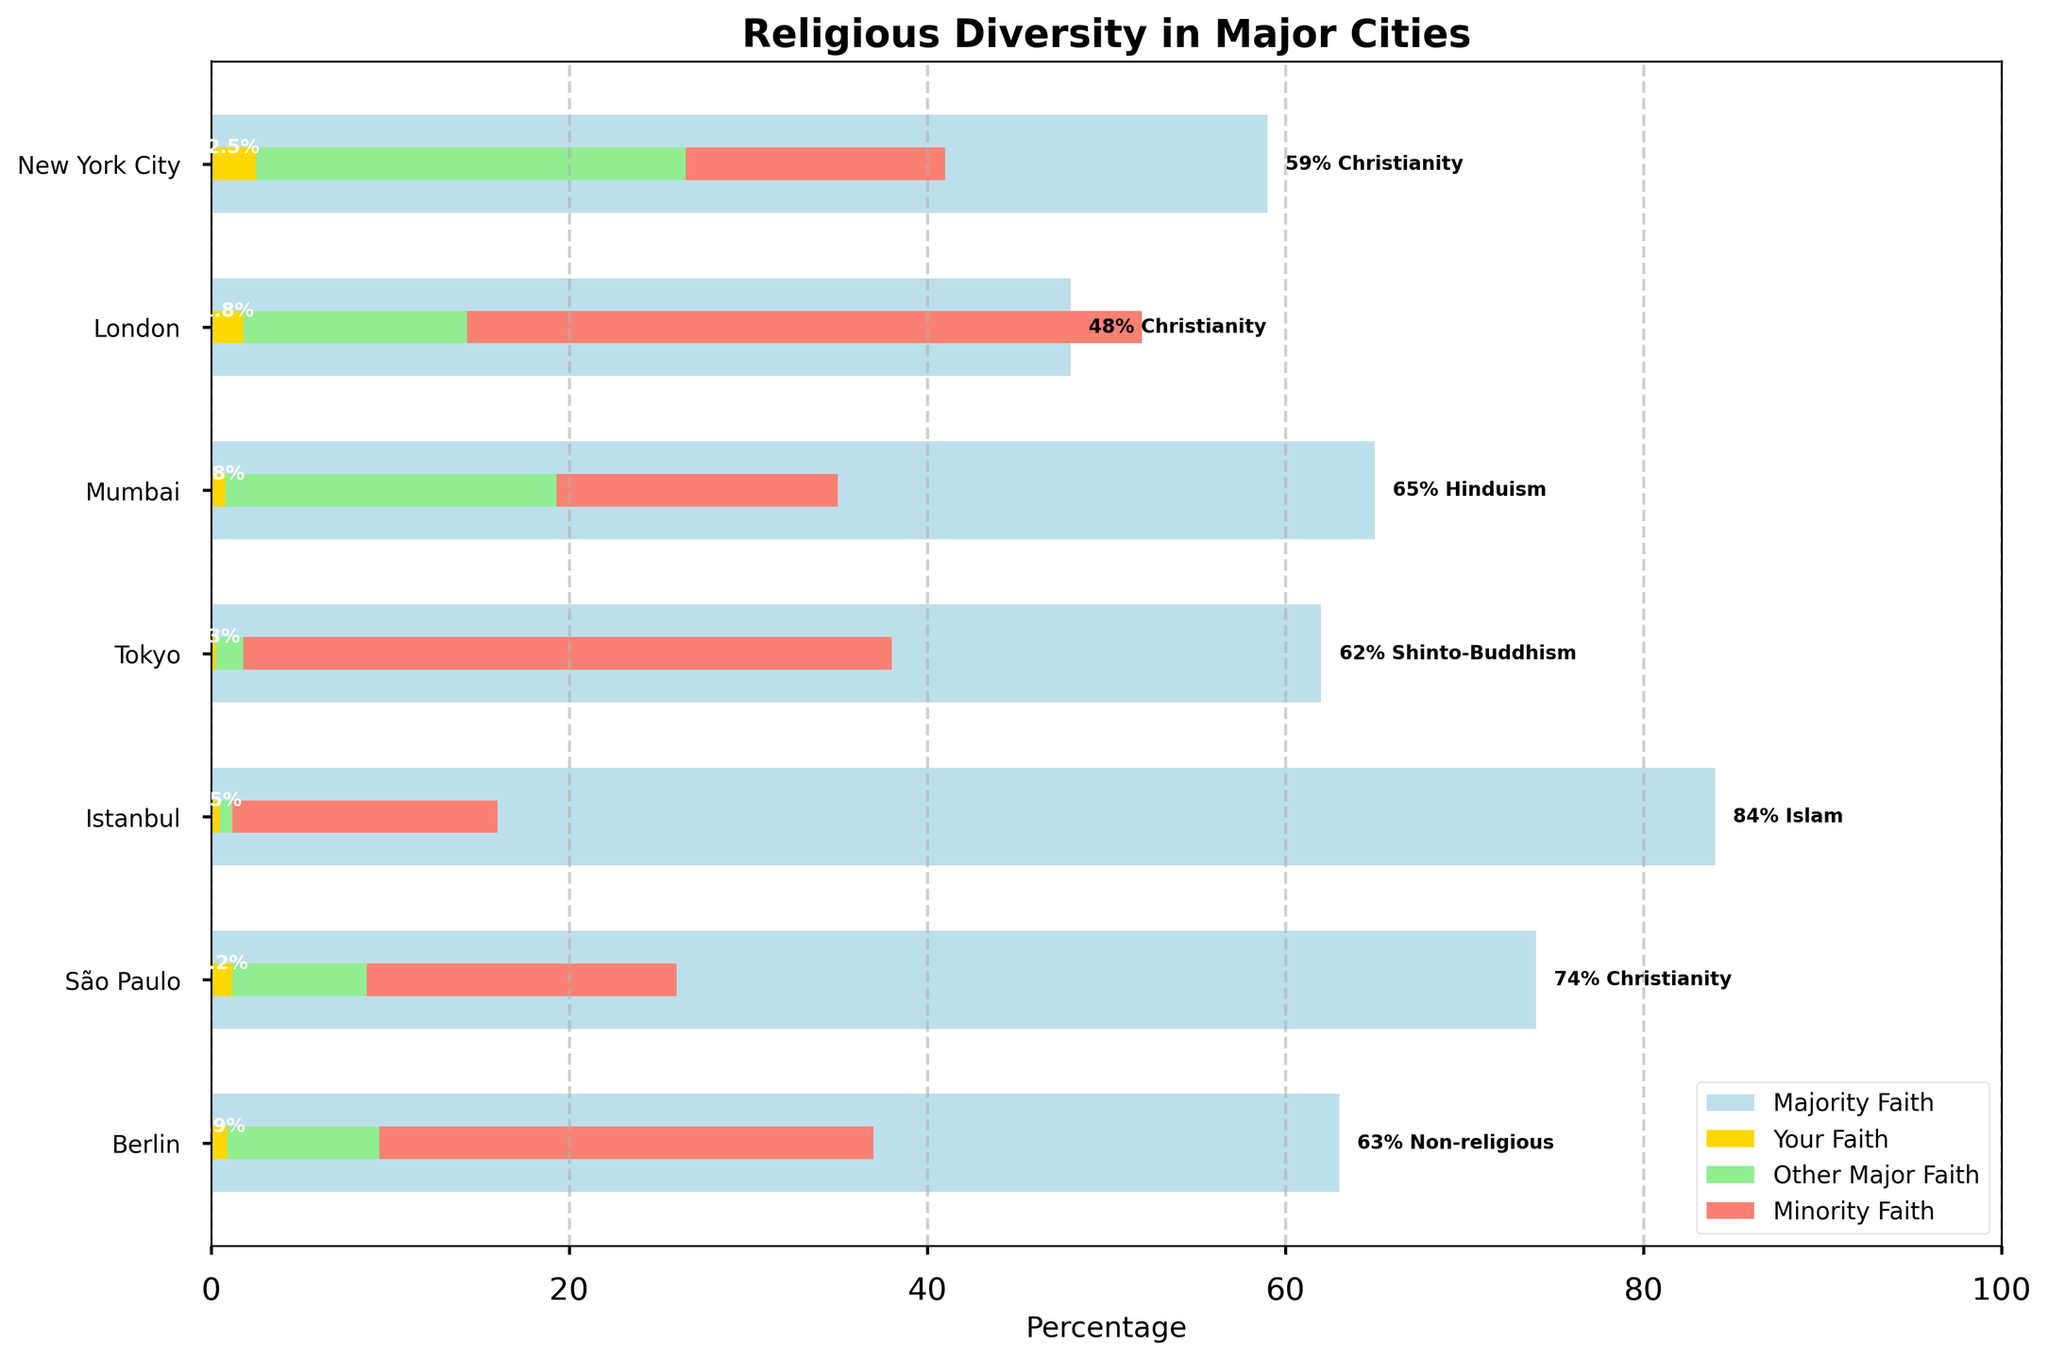What's the title of the figure? The title of the figure is typically displayed at the top. By referring to the figure, the title "Religious Diversity in Major Cities" is present.
Answer: Religious Diversity in Major Cities What city has the highest percentage of the majority faith? To answer this question, look for the city that has the largest blue bar, which represents the majority faith. The longest blue bar belongs to Istanbul.
Answer: Istanbul What is the percentage of your faith in Berlin? Find the bar corresponding to Berlin and check the segment that represents "Your Faith" in gold color. The percentage provided there is 0.9%.
Answer: 0.9% Which city has the smallest percentage of "Other Major Faith"? By comparing the green segments of each bar, the city with the smallest green segment is Tokyo, which has 1.5%.
Answer: Tokyo What percentage of New York City's population follows the majority faith? By looking at the blue segment of the bar for New York City, the percentage indicated is 59%.
Answer: 59% What is the combined percentage of "Your Faith" and "Other Major Faith" in Mumbai? Check the two segments in Mumbai's bar. "Your Faith" is 0.8% and "Other Major Faith" is 18.5%. Add them together: 0.8 + 18.5 = 19.3%.
Answer: 19.3% In which city is the percentage of "Minority Faith" higher, São Paulo or London? Compare the red segments of the bars for São Paulo and London. São Paulo's minority faith percentage is 17.3%, while London's is 37.7%. Therefore, it is higher in London.
Answer: London What's the total percentage of non-majority faiths in Tokyo? Adding the percentages of "Your Faith," "Other Major Faith," and "Minority Faith" for Tokyo: 0.3% + 1.5% + 36.2% = 38%.
Answer: 38% Which city has a lower percentage of the majority faith, New York City or Berlin? Comparing the blue segments of the bars for both cities, New York City's majority faith percentage is 59% and Berlin's is 63%. Thus, New York City has the lower percentage.
Answer: New York City How much higher is the percentage of Christianity in São Paulo compared to London? The blue bar representing Christianity in São Paulo is 74%, and in London, it is 48%. Therefore, the difference is 74 - 48 = 26%.
Answer: 26% 